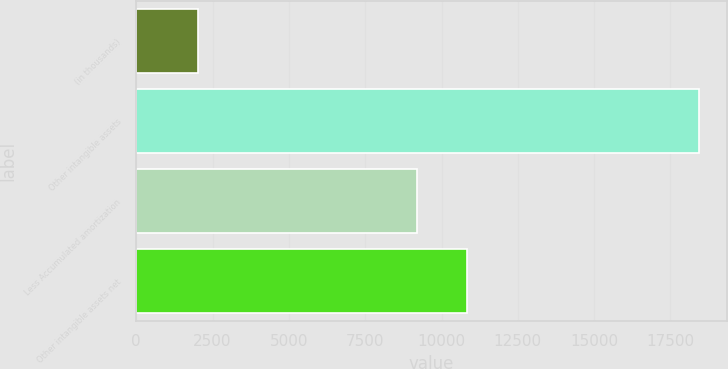<chart> <loc_0><loc_0><loc_500><loc_500><bar_chart><fcel>(in thousands)<fcel>Other intangible assets<fcel>Less Accumulated amortization<fcel>Other intangible assets net<nl><fcel>2007<fcel>18421<fcel>9189<fcel>10830.4<nl></chart> 